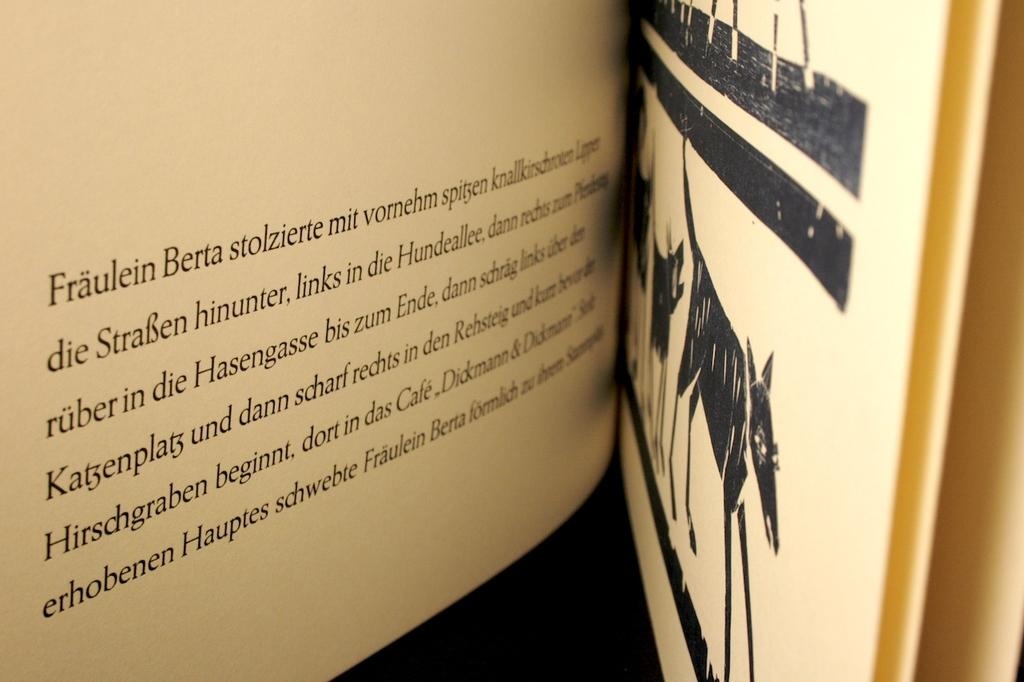<image>
Create a compact narrative representing the image presented. A book, in German, starts out with Fraulein Berta on the page in view. 